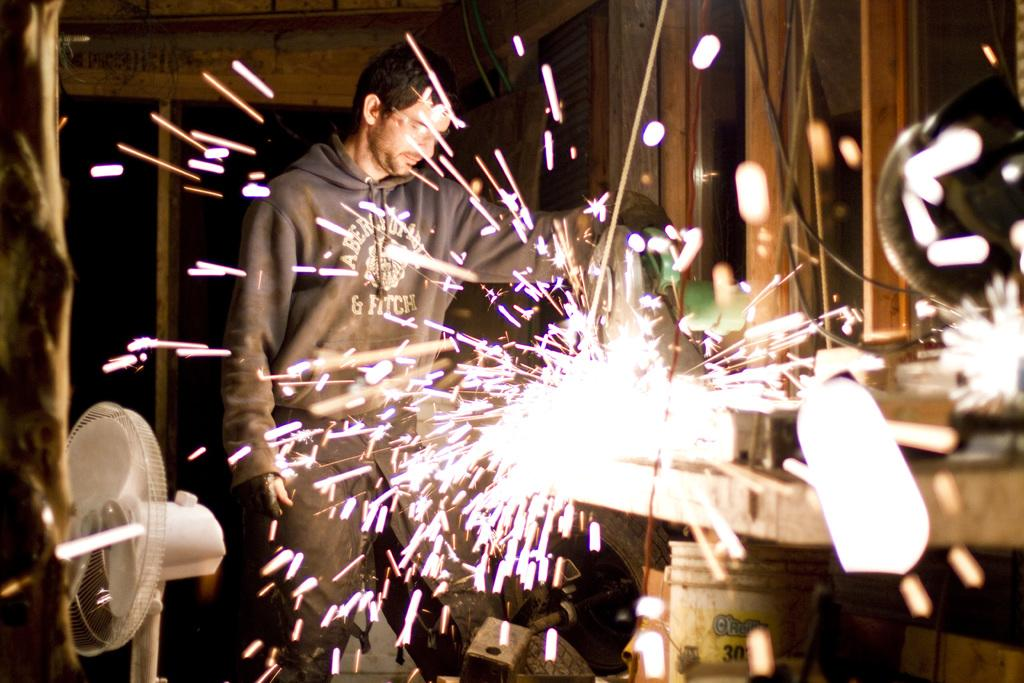What is the main subject of the image? The main subject of the image is a man. Can you describe the man's attire? The man is wearing a jacket and spectacles. What is the man's posture in the image? The man is standing. What objects can be seen in the image besides the man? There are windows, a bucket, and a fan in the image. How would you describe the lighting in the image? The background of the image is dark. What type of vegetable is being served in the pie in the image? There is no pie or vegetable present in the image. What activity are the children participating in during recess in the image? There are no children or recess depicted in the image. 